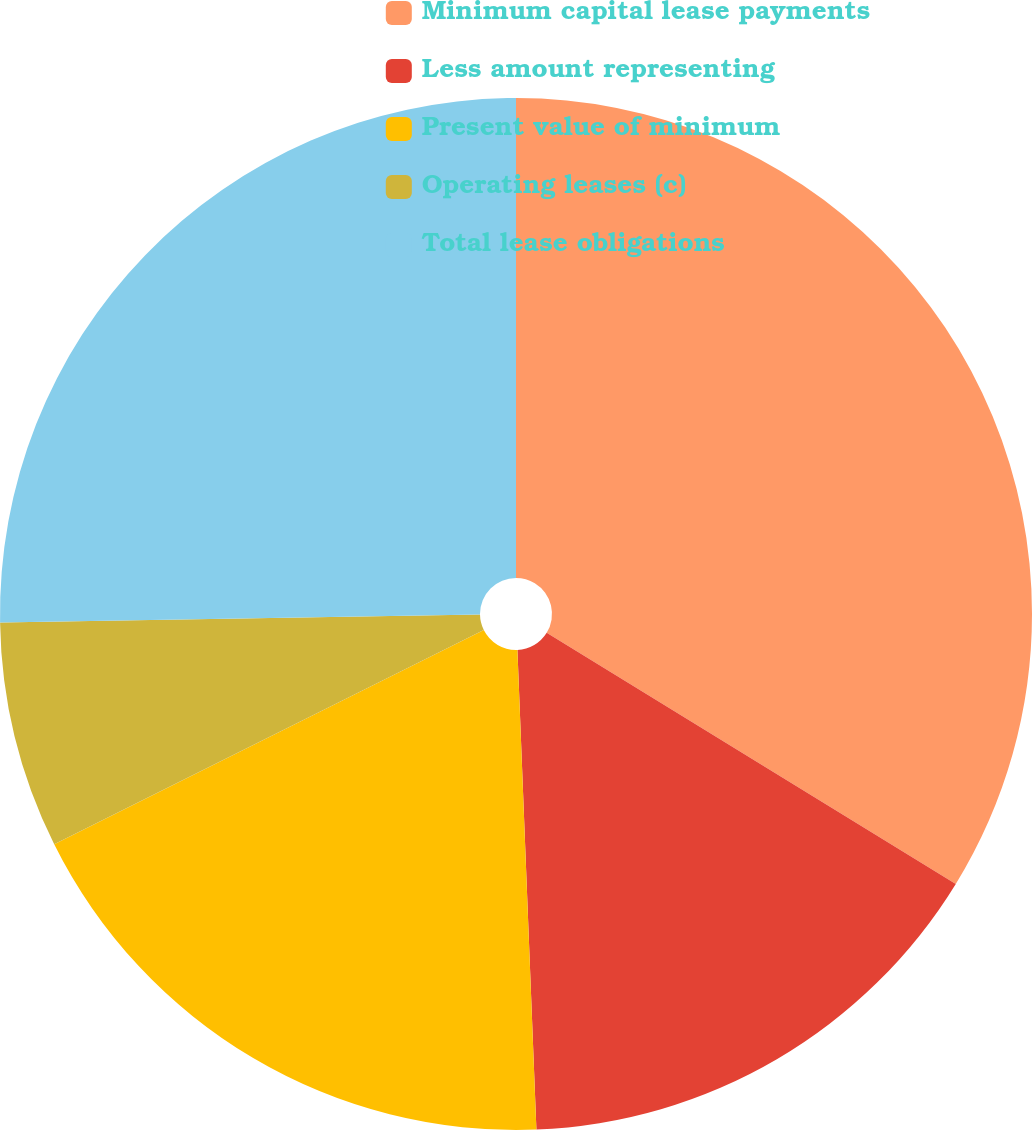<chart> <loc_0><loc_0><loc_500><loc_500><pie_chart><fcel>Minimum capital lease payments<fcel>Less amount representing<fcel>Present value of minimum<fcel>Operating leases (c)<fcel>Total lease obligations<nl><fcel>33.76%<fcel>15.61%<fcel>18.27%<fcel>7.1%<fcel>25.26%<nl></chart> 